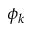Convert formula to latex. <formula><loc_0><loc_0><loc_500><loc_500>\phi _ { k }</formula> 